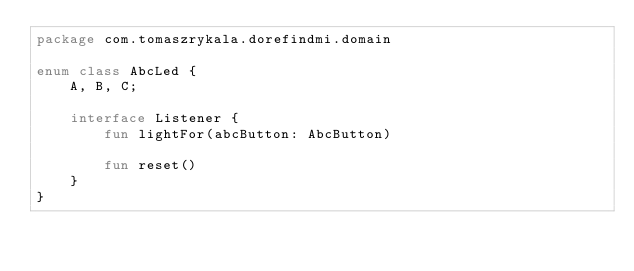<code> <loc_0><loc_0><loc_500><loc_500><_Kotlin_>package com.tomaszrykala.dorefindmi.domain

enum class AbcLed {
    A, B, C;

    interface Listener {
        fun lightFor(abcButton: AbcButton)

        fun reset()
    }
}
</code> 